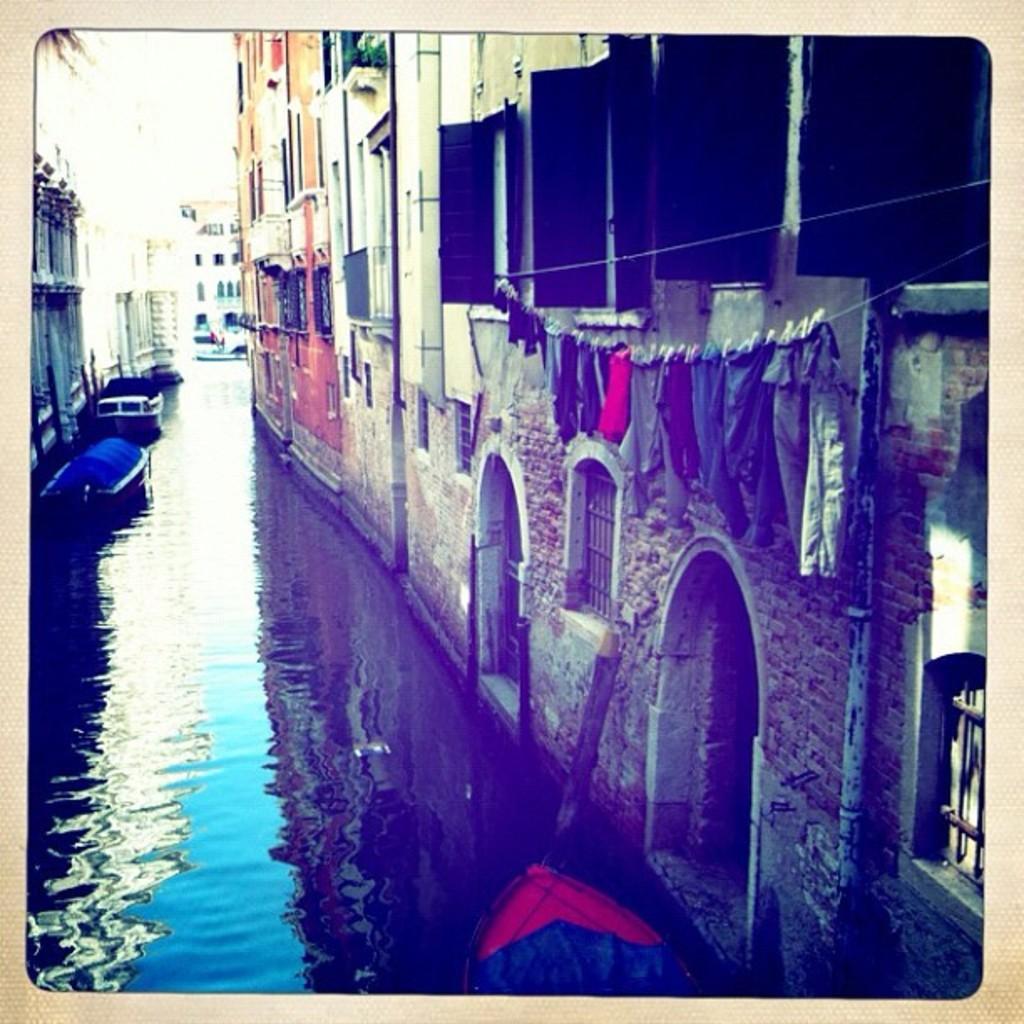In one or two sentences, can you explain what this image depicts? In the picture we can see a part of the building with windows and some clothes are hanged and near the building we can see water in it we can see some boats and opposite side also we can see some houses and in the background we can see a building. 